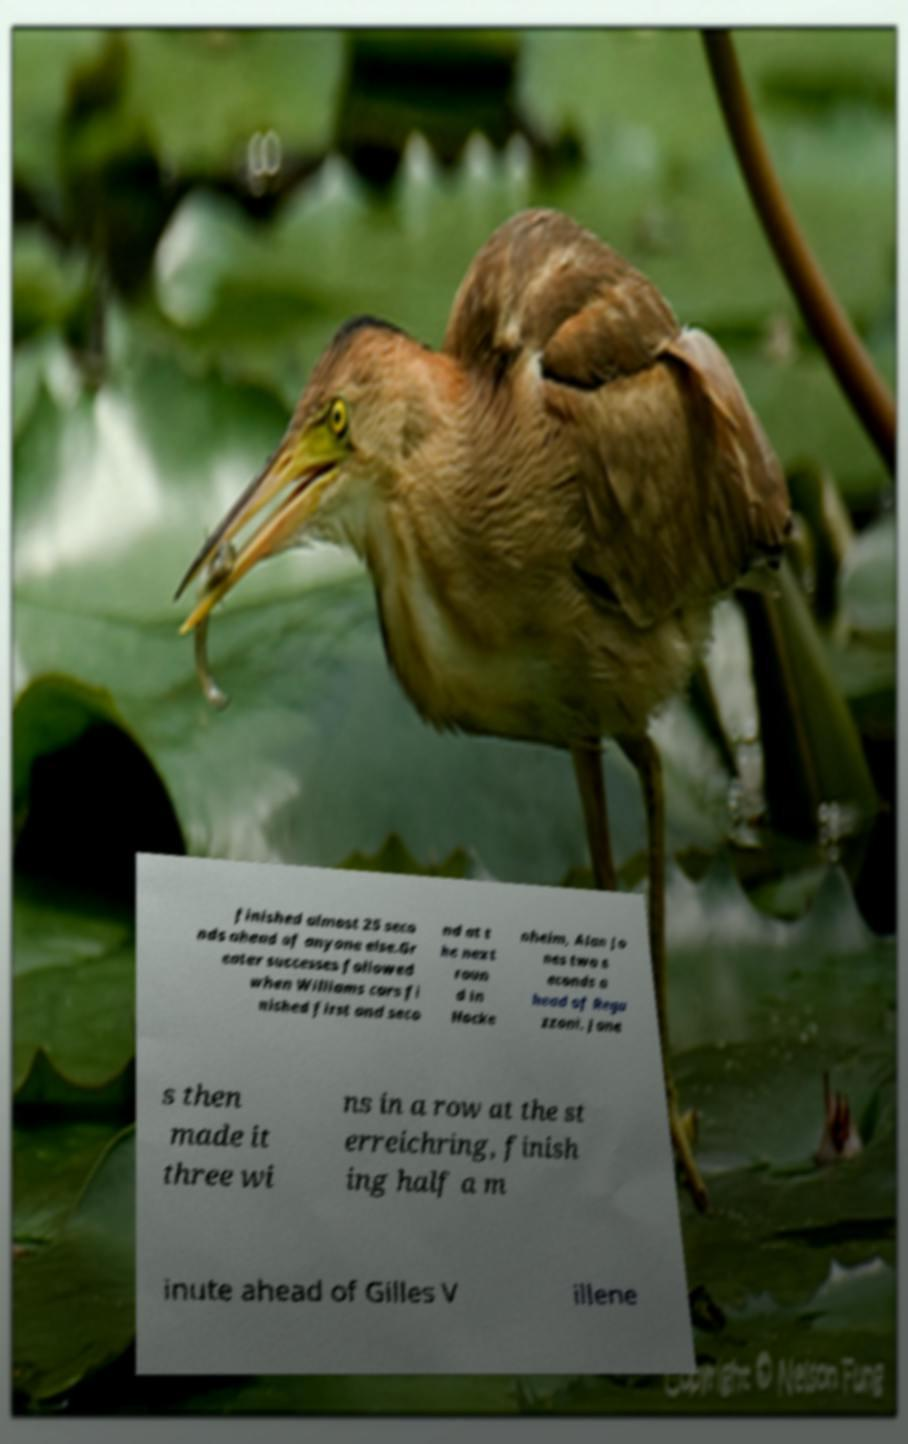I need the written content from this picture converted into text. Can you do that? finished almost 25 seco nds ahead of anyone else.Gr eater successes followed when Williams cars fi nished first and seco nd at t he next roun d in Hocke nheim, Alan Jo nes two s econds a head of Rega zzoni. Jone s then made it three wi ns in a row at the st erreichring, finish ing half a m inute ahead of Gilles V illene 